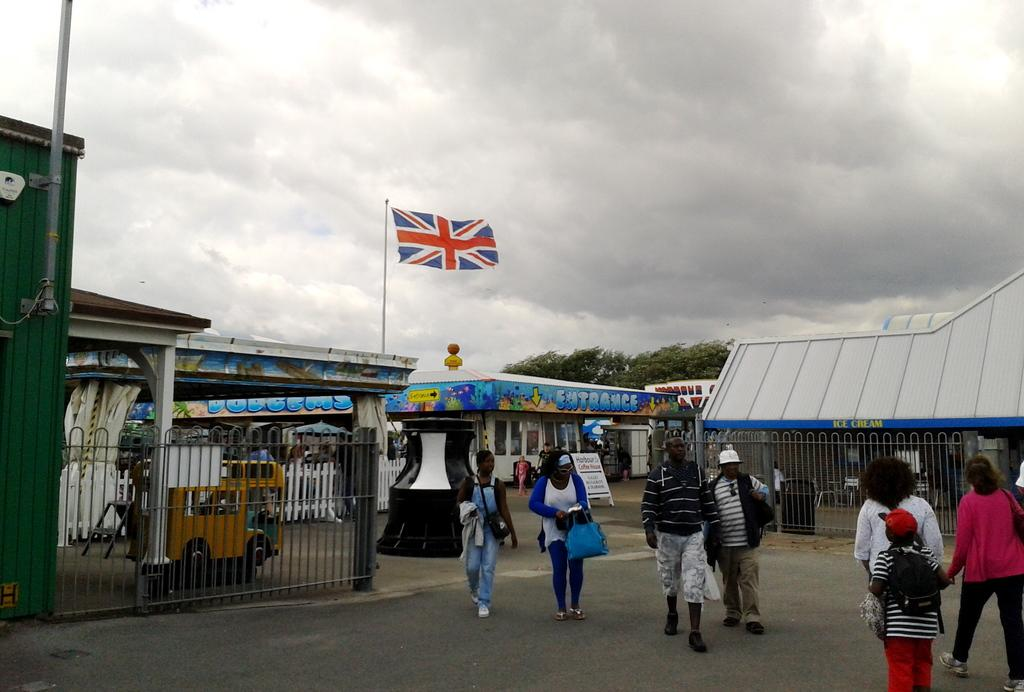<image>
Offer a succinct explanation of the picture presented. a flag is above the word entrance below it 